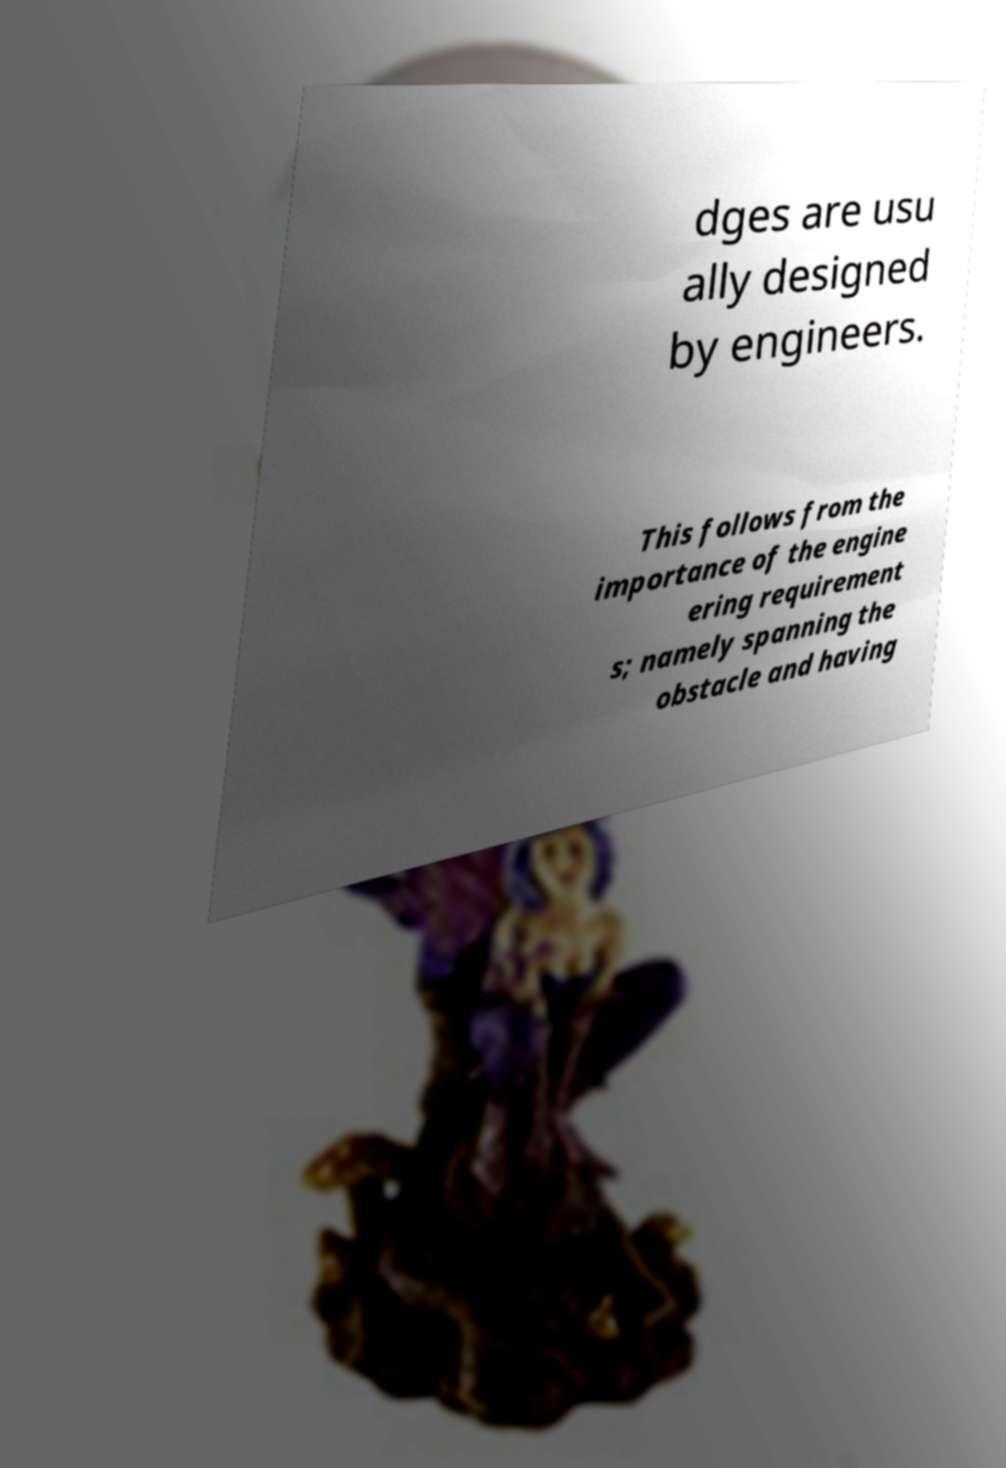Can you accurately transcribe the text from the provided image for me? dges are usu ally designed by engineers. This follows from the importance of the engine ering requirement s; namely spanning the obstacle and having 